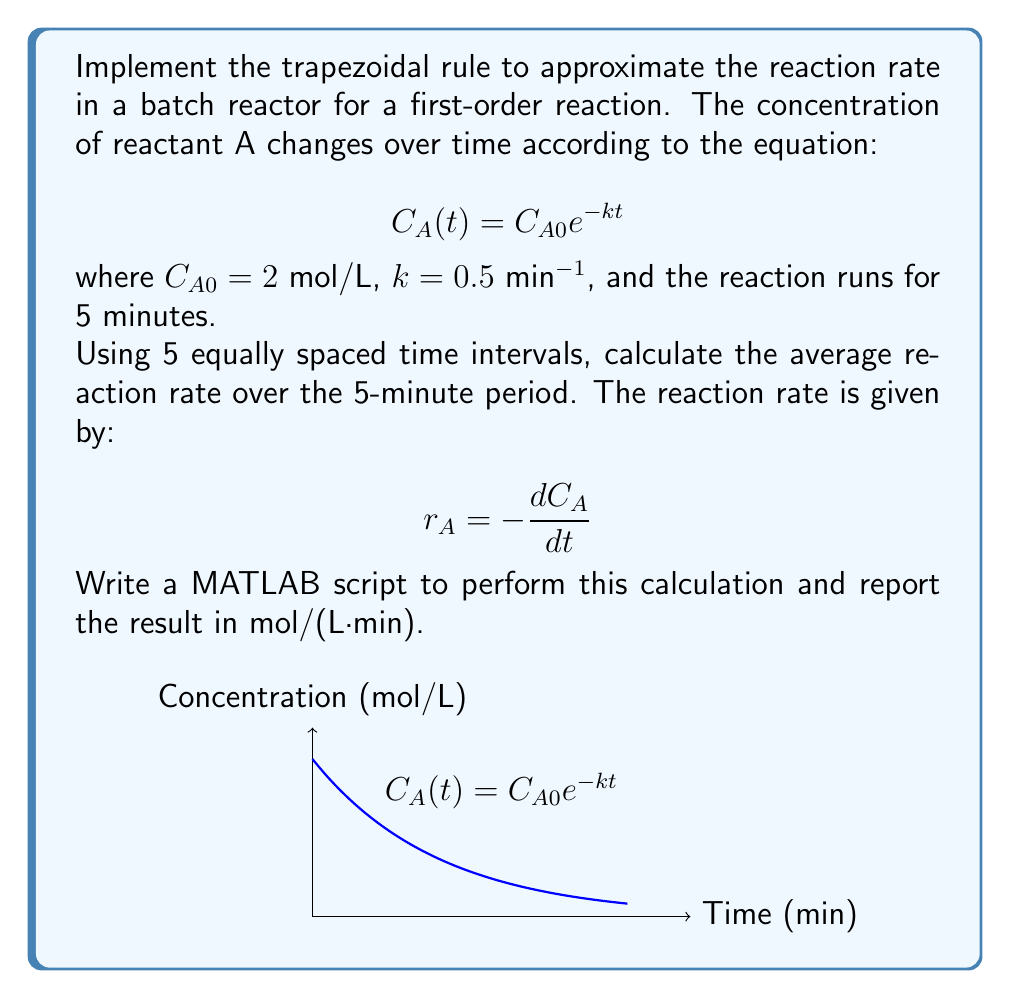Give your solution to this math problem. To solve this problem, we'll follow these steps:

1) Set up the time intervals:
   We need 5 equally spaced intervals over 5 minutes, so our time points will be:
   $t = [0, 1, 2, 3, 4, 5]$ minutes

2) Calculate the concentration at each time point:
   $C_A(t) = 2 e^{-0.5t}$

3) Calculate the reaction rate at each time point:
   $r_A(t) = -\frac{dC_A}{dt} = -\frac{d}{dt}(2e^{-0.5t}) = 2 \cdot 0.5 e^{-0.5t} = e^{-0.5t}$

4) Apply the trapezoidal rule:
   $$\text{Average rate} = \frac{1}{5} \cdot \frac{1}{2} \sum_{i=1}^{5} (r_A(t_i) + r_A(t_{i-1}))$$

Here's the MATLAB script to perform these calculations:

```matlab
% Define parameters
C_A0 = 2;
k = 0.5;
t = 0:1:5;

% Calculate concentrations
C_A = C_A0 * exp(-k*t);

% Calculate reaction rates
r_A = k * C_A;

% Apply trapezoidal rule
avg_rate = trapz(t, r_A) / (t(end) - t(1));

% Display result
fprintf('Average reaction rate: %.4f mol/(L·min)\n', avg_rate);
```

This script calculates the average reaction rate using MATLAB's built-in `trapz` function, which applies the trapezoidal rule.

The trapezoidal rule approximates the area under the curve by dividing it into trapezoids and summing their areas. In this case, we're finding the area under the reaction rate curve and dividing by the total time to get the average rate.
Answer: 0.6321 mol/(L·min) 